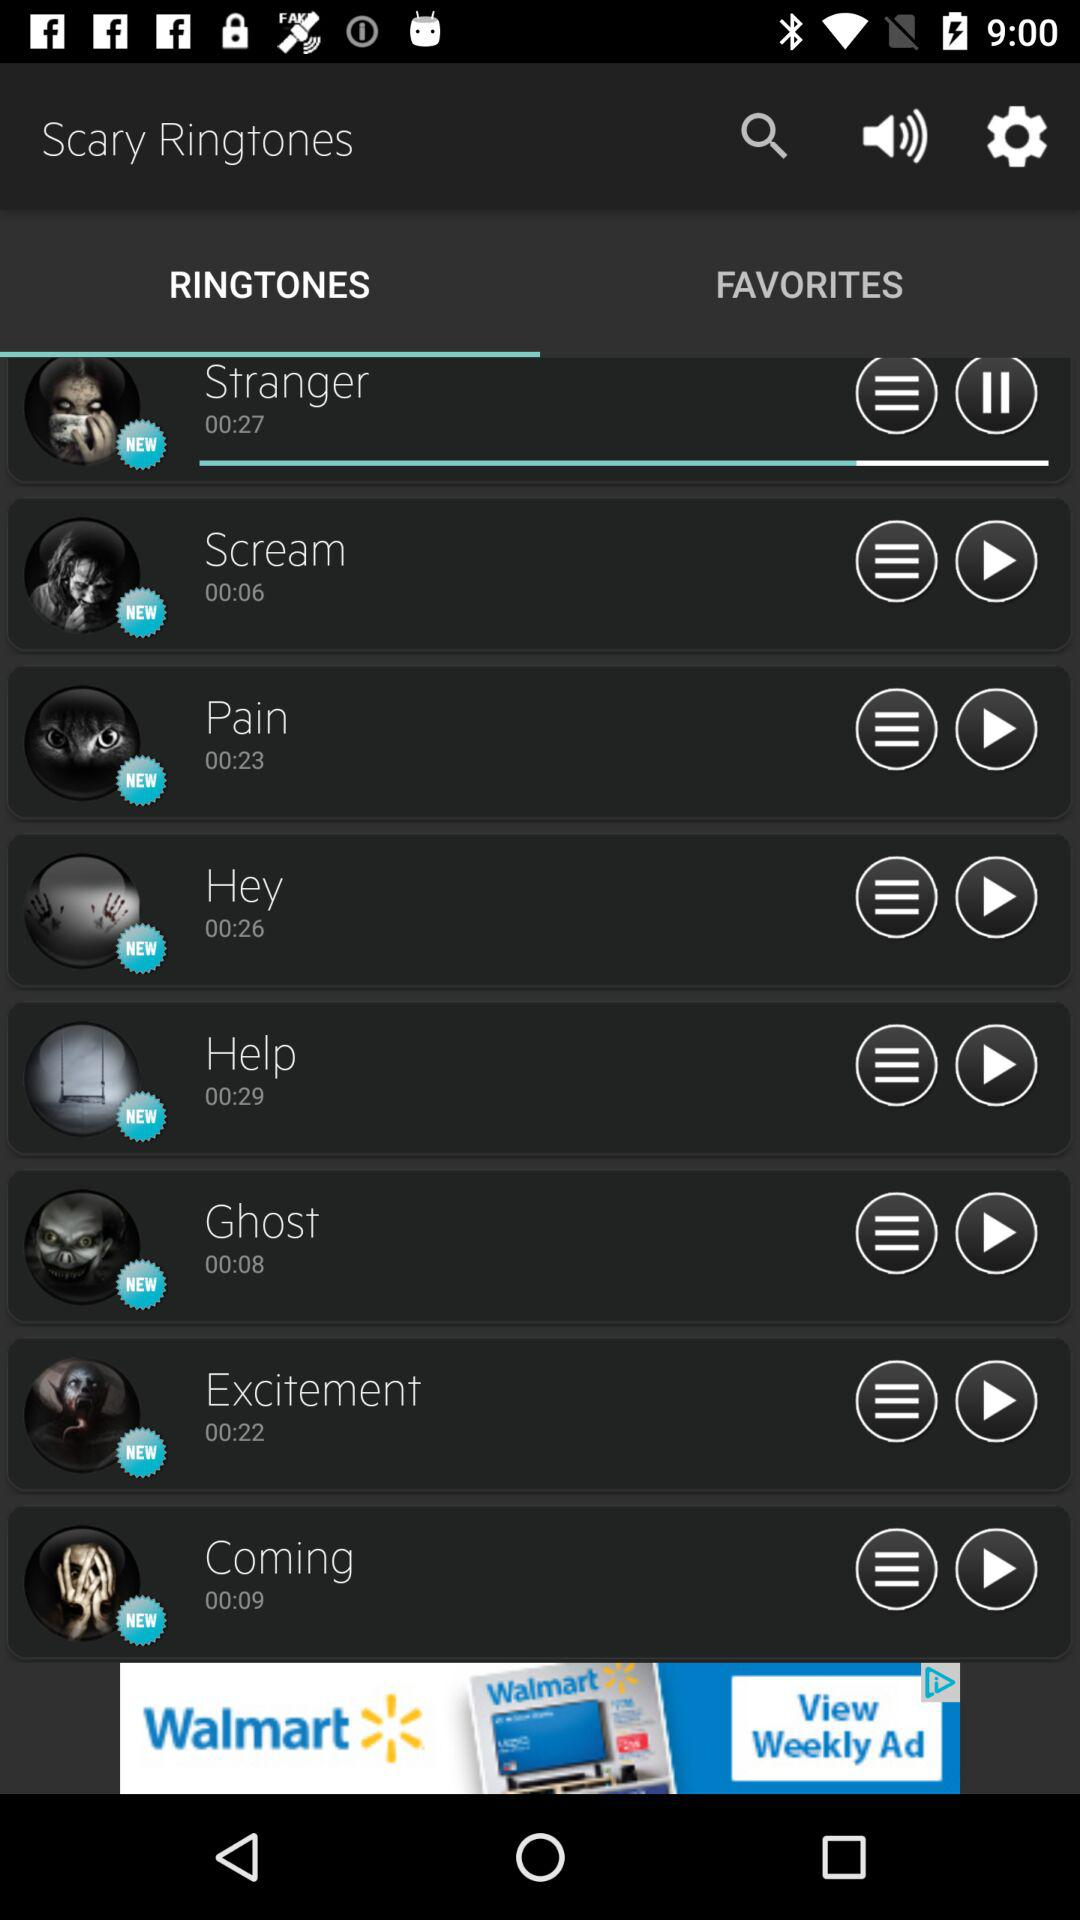Which ringtone has the longest duration?
When the provided information is insufficient, respond with <no answer>. <no answer> 